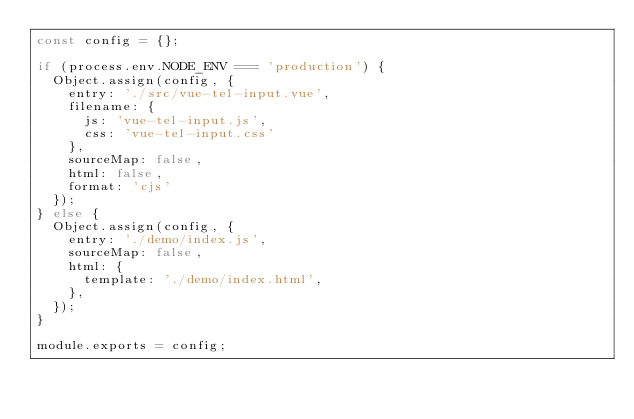Convert code to text. <code><loc_0><loc_0><loc_500><loc_500><_JavaScript_>const config = {};

if (process.env.NODE_ENV === 'production') {
  Object.assign(config, {
    entry: './src/vue-tel-input.vue',
    filename: {
      js: 'vue-tel-input.js',
      css: 'vue-tel-input.css'
    },
    sourceMap: false,
    html: false,
    format: 'cjs'
  });
} else {
  Object.assign(config, {
    entry: './demo/index.js',
    sourceMap: false,
    html: {
      template: './demo/index.html',
    },
  });
}

module.exports = config;
</code> 